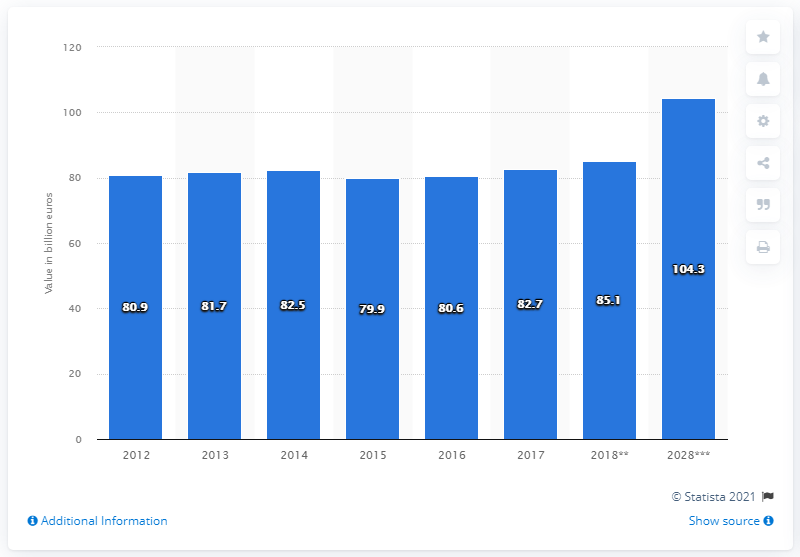Point out several critical features in this image. In 2017, the direct contribution of the travel and tourism industry to France's GDP was 82.7%. 